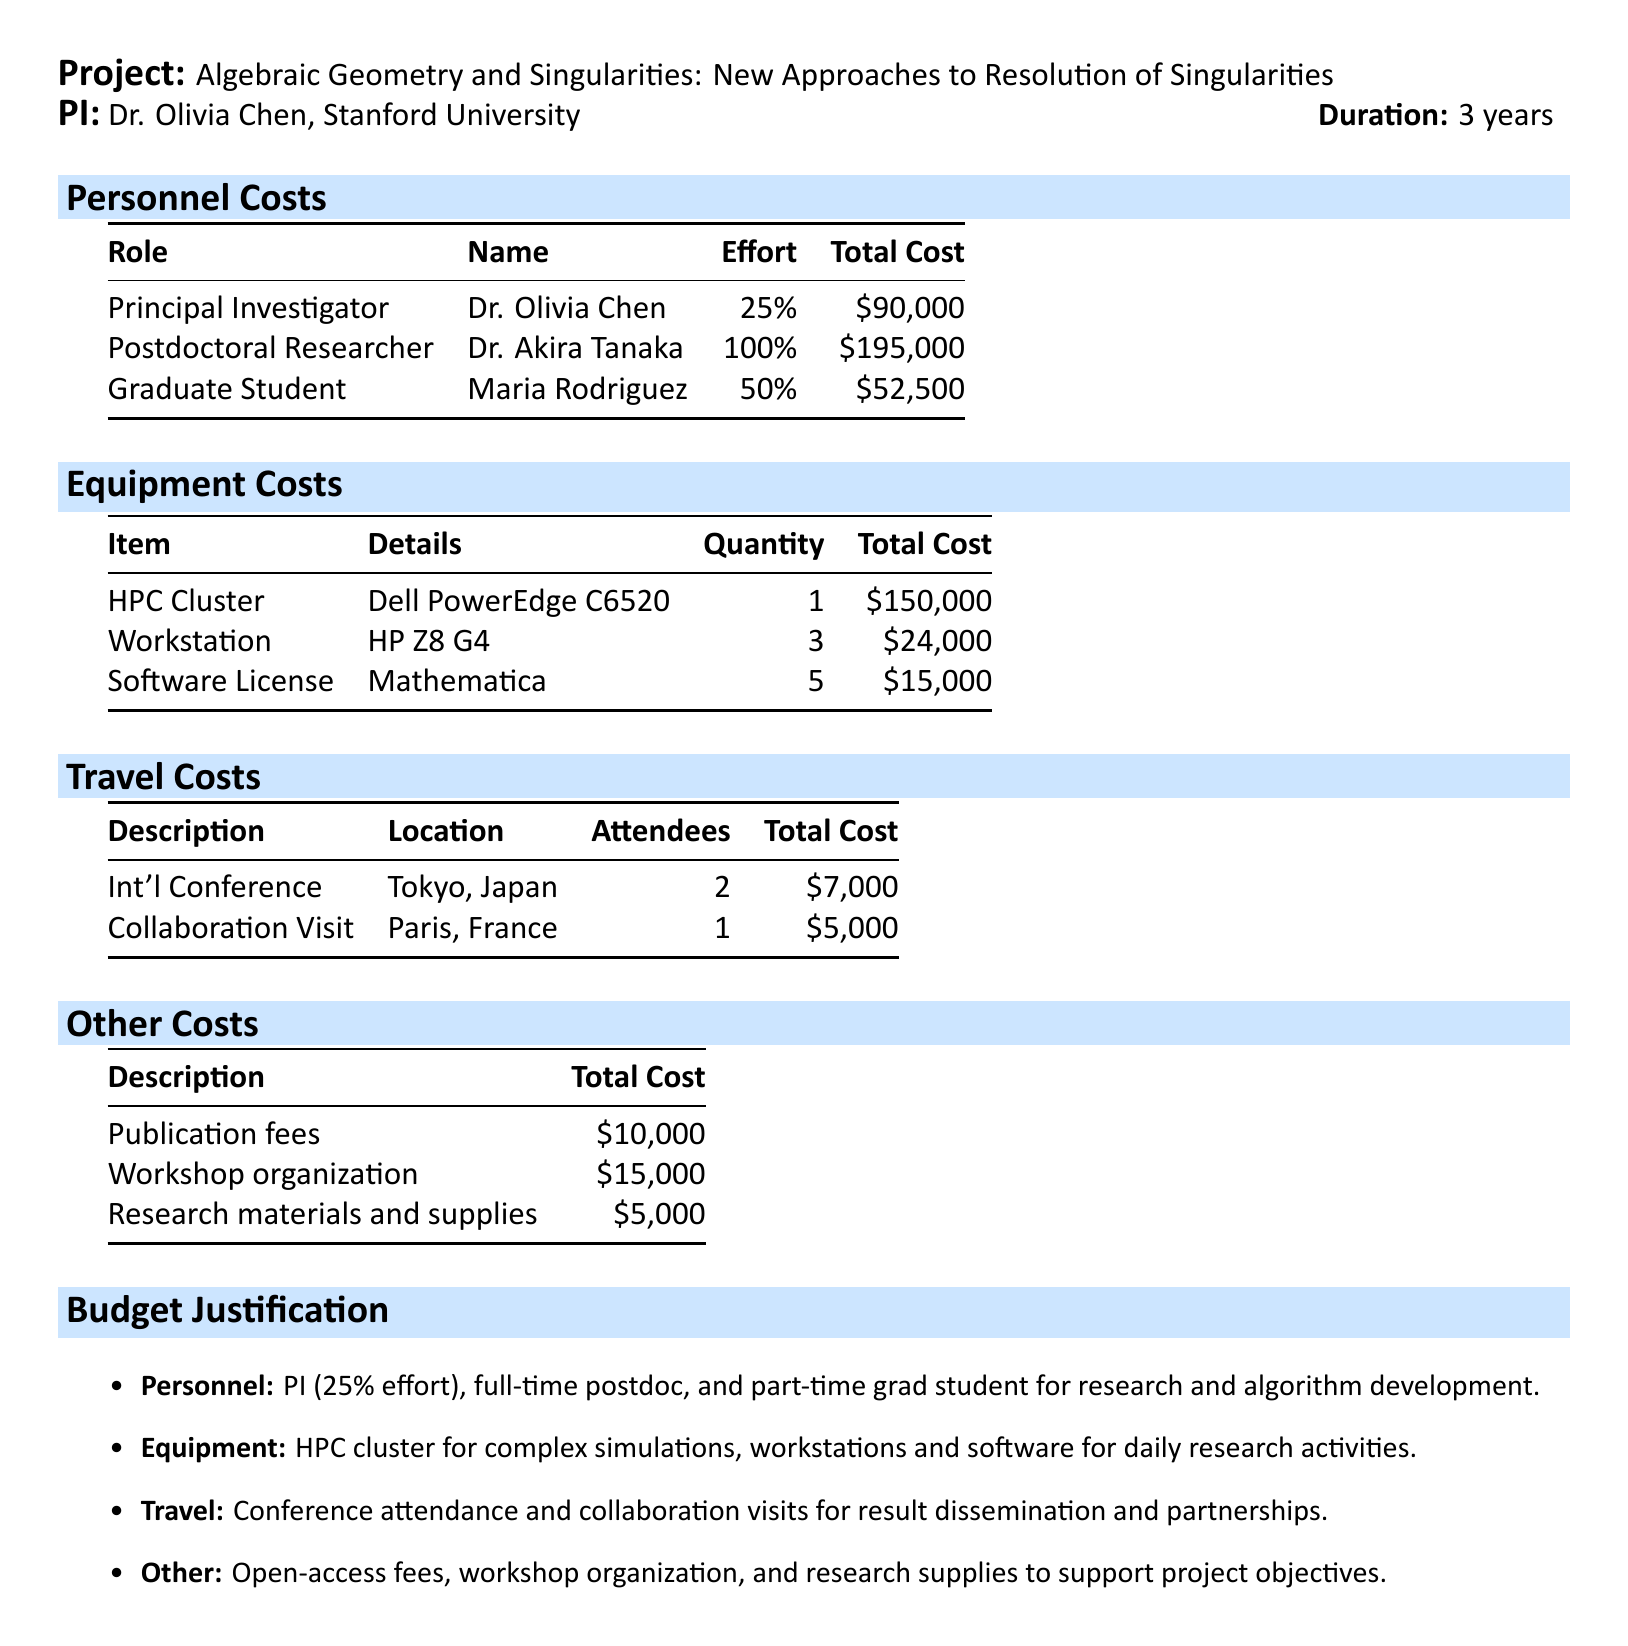What is the project title? The project title is stated clearly at the beginning of the document, which is "Algebraic Geometry and Singularities: New Approaches to Resolution of Singularities."
Answer: Algebraic Geometry and Singularities: New Approaches to Resolution of Singularities Who is the principal investigator? The principal investigator is mentioned in the document, Dr. Olivia Chen.
Answer: Dr. Olivia Chen What is the total budget of the project? The total budget is provided in the header of the document as $750,000.
Answer: $750,000 How much is allocated for the postdoctoral researcher? The total cost for the postdoctoral researcher is explicitly given in the personnel costs section as $195,000.
Answer: $195,000 What equipment costs the highest amount? The highest equipment cost item is the high-performance computing cluster, totaling $150,000.
Answer: High-Performance Computing Cluster How many workstations are included in the budget? The document lists the quantity of workstations under equipment costs, which is 3.
Answer: 3 What is the total cost for travel to the International Conference in Tokyo? The total travel cost for the International Conference is provided as $7,000 in the travel costs section.
Answer: $7,000 What is the purpose of the workshop organization listed under other costs? The workshop is mentioned in the justification section to promote knowledge exchange and collaboration among experts in the field.
Answer: Knowledge exchange and collaboration What percentage of effort does Dr. Olivia Chen dedicate to the project? The document states that Dr. Olivia Chen dedicates 25% of her time to oversee the project.
Answer: 25% What type of software license is included in the budget? The document specifies that a Mathematica software license is part of the equipment costs.
Answer: Mathematica 